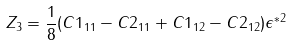Convert formula to latex. <formula><loc_0><loc_0><loc_500><loc_500>Z _ { 3 } = \frac { 1 } { 8 } ( C 1 _ { 1 1 } - C 2 _ { 1 1 } + C 1 _ { 1 2 } - C 2 _ { 1 2 } ) \epsilon ^ { * 2 }</formula> 